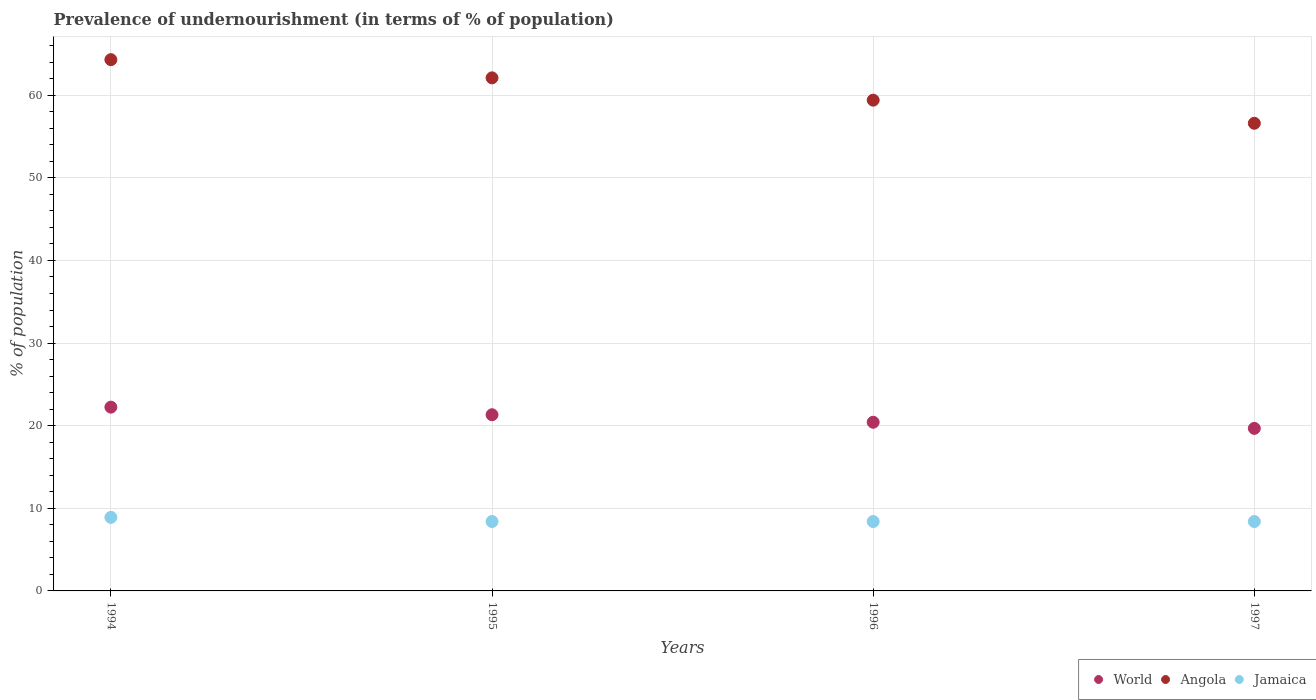Is the number of dotlines equal to the number of legend labels?
Your answer should be very brief. Yes. What is the percentage of undernourished population in Angola in 1996?
Ensure brevity in your answer.  59.4. Across all years, what is the minimum percentage of undernourished population in Angola?
Ensure brevity in your answer.  56.6. In which year was the percentage of undernourished population in World minimum?
Keep it short and to the point. 1997. What is the total percentage of undernourished population in Jamaica in the graph?
Provide a succinct answer. 34.1. What is the difference between the percentage of undernourished population in Jamaica in 1994 and that in 1996?
Provide a succinct answer. 0.5. What is the difference between the percentage of undernourished population in Angola in 1997 and the percentage of undernourished population in Jamaica in 1996?
Keep it short and to the point. 48.2. What is the average percentage of undernourished population in Jamaica per year?
Your response must be concise. 8.53. In the year 1995, what is the difference between the percentage of undernourished population in Jamaica and percentage of undernourished population in Angola?
Offer a terse response. -53.7. What is the ratio of the percentage of undernourished population in Jamaica in 1994 to that in 1995?
Your answer should be very brief. 1.06. Is the percentage of undernourished population in Jamaica in 1995 less than that in 1997?
Offer a terse response. No. What is the difference between the highest and the lowest percentage of undernourished population in World?
Make the answer very short. 2.57. Is it the case that in every year, the sum of the percentage of undernourished population in World and percentage of undernourished population in Jamaica  is greater than the percentage of undernourished population in Angola?
Provide a succinct answer. No. Does the percentage of undernourished population in Angola monotonically increase over the years?
Make the answer very short. No. Is the percentage of undernourished population in World strictly greater than the percentage of undernourished population in Angola over the years?
Give a very brief answer. No. How many dotlines are there?
Make the answer very short. 3. Are the values on the major ticks of Y-axis written in scientific E-notation?
Your answer should be very brief. No. Does the graph contain any zero values?
Ensure brevity in your answer.  No. Does the graph contain grids?
Provide a succinct answer. Yes. Where does the legend appear in the graph?
Give a very brief answer. Bottom right. How are the legend labels stacked?
Offer a terse response. Horizontal. What is the title of the graph?
Keep it short and to the point. Prevalence of undernourishment (in terms of % of population). What is the label or title of the X-axis?
Keep it short and to the point. Years. What is the label or title of the Y-axis?
Provide a succinct answer. % of population. What is the % of population in World in 1994?
Ensure brevity in your answer.  22.24. What is the % of population in Angola in 1994?
Offer a terse response. 64.3. What is the % of population in World in 1995?
Your answer should be compact. 21.32. What is the % of population in Angola in 1995?
Provide a succinct answer. 62.1. What is the % of population in World in 1996?
Offer a very short reply. 20.42. What is the % of population of Angola in 1996?
Keep it short and to the point. 59.4. What is the % of population in Jamaica in 1996?
Offer a very short reply. 8.4. What is the % of population of World in 1997?
Your answer should be very brief. 19.67. What is the % of population in Angola in 1997?
Provide a succinct answer. 56.6. What is the % of population of Jamaica in 1997?
Make the answer very short. 8.4. Across all years, what is the maximum % of population of World?
Provide a succinct answer. 22.24. Across all years, what is the maximum % of population of Angola?
Make the answer very short. 64.3. Across all years, what is the minimum % of population in World?
Offer a very short reply. 19.67. Across all years, what is the minimum % of population of Angola?
Keep it short and to the point. 56.6. What is the total % of population of World in the graph?
Your response must be concise. 83.66. What is the total % of population of Angola in the graph?
Give a very brief answer. 242.4. What is the total % of population of Jamaica in the graph?
Your answer should be compact. 34.1. What is the difference between the % of population of World in 1994 and that in 1995?
Ensure brevity in your answer.  0.92. What is the difference between the % of population in Jamaica in 1994 and that in 1995?
Provide a succinct answer. 0.5. What is the difference between the % of population of World in 1994 and that in 1996?
Ensure brevity in your answer.  1.83. What is the difference between the % of population of Angola in 1994 and that in 1996?
Your response must be concise. 4.9. What is the difference between the % of population of Jamaica in 1994 and that in 1996?
Offer a terse response. 0.5. What is the difference between the % of population in World in 1994 and that in 1997?
Your answer should be very brief. 2.57. What is the difference between the % of population of Angola in 1994 and that in 1997?
Offer a terse response. 7.7. What is the difference between the % of population in World in 1995 and that in 1996?
Provide a succinct answer. 0.91. What is the difference between the % of population in Jamaica in 1995 and that in 1996?
Offer a very short reply. 0. What is the difference between the % of population of World in 1995 and that in 1997?
Give a very brief answer. 1.65. What is the difference between the % of population of Jamaica in 1995 and that in 1997?
Provide a succinct answer. 0. What is the difference between the % of population of World in 1996 and that in 1997?
Offer a very short reply. 0.74. What is the difference between the % of population of World in 1994 and the % of population of Angola in 1995?
Provide a short and direct response. -39.86. What is the difference between the % of population in World in 1994 and the % of population in Jamaica in 1995?
Provide a succinct answer. 13.84. What is the difference between the % of population of Angola in 1994 and the % of population of Jamaica in 1995?
Ensure brevity in your answer.  55.9. What is the difference between the % of population of World in 1994 and the % of population of Angola in 1996?
Offer a very short reply. -37.16. What is the difference between the % of population in World in 1994 and the % of population in Jamaica in 1996?
Give a very brief answer. 13.84. What is the difference between the % of population in Angola in 1994 and the % of population in Jamaica in 1996?
Provide a short and direct response. 55.9. What is the difference between the % of population of World in 1994 and the % of population of Angola in 1997?
Provide a succinct answer. -34.36. What is the difference between the % of population in World in 1994 and the % of population in Jamaica in 1997?
Keep it short and to the point. 13.84. What is the difference between the % of population of Angola in 1994 and the % of population of Jamaica in 1997?
Your answer should be compact. 55.9. What is the difference between the % of population of World in 1995 and the % of population of Angola in 1996?
Your answer should be very brief. -38.08. What is the difference between the % of population of World in 1995 and the % of population of Jamaica in 1996?
Your answer should be very brief. 12.92. What is the difference between the % of population in Angola in 1995 and the % of population in Jamaica in 1996?
Offer a very short reply. 53.7. What is the difference between the % of population of World in 1995 and the % of population of Angola in 1997?
Provide a succinct answer. -35.28. What is the difference between the % of population of World in 1995 and the % of population of Jamaica in 1997?
Provide a succinct answer. 12.92. What is the difference between the % of population in Angola in 1995 and the % of population in Jamaica in 1997?
Your response must be concise. 53.7. What is the difference between the % of population in World in 1996 and the % of population in Angola in 1997?
Ensure brevity in your answer.  -36.18. What is the difference between the % of population of World in 1996 and the % of population of Jamaica in 1997?
Provide a short and direct response. 12.02. What is the average % of population in World per year?
Make the answer very short. 20.91. What is the average % of population of Angola per year?
Make the answer very short. 60.6. What is the average % of population of Jamaica per year?
Give a very brief answer. 8.53. In the year 1994, what is the difference between the % of population in World and % of population in Angola?
Your answer should be very brief. -42.06. In the year 1994, what is the difference between the % of population of World and % of population of Jamaica?
Provide a short and direct response. 13.34. In the year 1994, what is the difference between the % of population in Angola and % of population in Jamaica?
Offer a terse response. 55.4. In the year 1995, what is the difference between the % of population of World and % of population of Angola?
Your answer should be very brief. -40.78. In the year 1995, what is the difference between the % of population in World and % of population in Jamaica?
Provide a short and direct response. 12.92. In the year 1995, what is the difference between the % of population in Angola and % of population in Jamaica?
Your response must be concise. 53.7. In the year 1996, what is the difference between the % of population in World and % of population in Angola?
Offer a very short reply. -38.98. In the year 1996, what is the difference between the % of population in World and % of population in Jamaica?
Offer a terse response. 12.02. In the year 1997, what is the difference between the % of population of World and % of population of Angola?
Your response must be concise. -36.93. In the year 1997, what is the difference between the % of population of World and % of population of Jamaica?
Your response must be concise. 11.27. In the year 1997, what is the difference between the % of population in Angola and % of population in Jamaica?
Give a very brief answer. 48.2. What is the ratio of the % of population in World in 1994 to that in 1995?
Keep it short and to the point. 1.04. What is the ratio of the % of population in Angola in 1994 to that in 1995?
Your answer should be compact. 1.04. What is the ratio of the % of population in Jamaica in 1994 to that in 1995?
Offer a terse response. 1.06. What is the ratio of the % of population of World in 1994 to that in 1996?
Provide a succinct answer. 1.09. What is the ratio of the % of population in Angola in 1994 to that in 1996?
Ensure brevity in your answer.  1.08. What is the ratio of the % of population in Jamaica in 1994 to that in 1996?
Give a very brief answer. 1.06. What is the ratio of the % of population of World in 1994 to that in 1997?
Your answer should be very brief. 1.13. What is the ratio of the % of population of Angola in 1994 to that in 1997?
Your answer should be compact. 1.14. What is the ratio of the % of population of Jamaica in 1994 to that in 1997?
Your answer should be compact. 1.06. What is the ratio of the % of population in World in 1995 to that in 1996?
Make the answer very short. 1.04. What is the ratio of the % of population of Angola in 1995 to that in 1996?
Offer a terse response. 1.05. What is the ratio of the % of population in World in 1995 to that in 1997?
Ensure brevity in your answer.  1.08. What is the ratio of the % of population of Angola in 1995 to that in 1997?
Give a very brief answer. 1.1. What is the ratio of the % of population of Jamaica in 1995 to that in 1997?
Provide a succinct answer. 1. What is the ratio of the % of population in World in 1996 to that in 1997?
Your answer should be very brief. 1.04. What is the ratio of the % of population in Angola in 1996 to that in 1997?
Keep it short and to the point. 1.05. What is the ratio of the % of population in Jamaica in 1996 to that in 1997?
Offer a very short reply. 1. What is the difference between the highest and the second highest % of population in World?
Offer a very short reply. 0.92. What is the difference between the highest and the second highest % of population of Angola?
Provide a succinct answer. 2.2. What is the difference between the highest and the lowest % of population of World?
Keep it short and to the point. 2.57. What is the difference between the highest and the lowest % of population in Angola?
Provide a succinct answer. 7.7. 